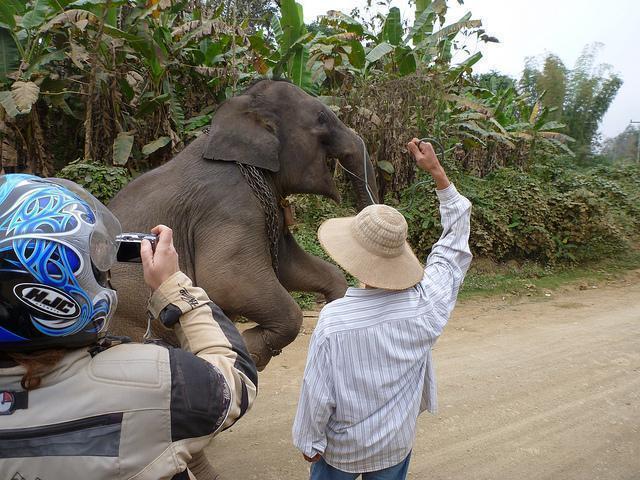Why does the man use a rope?
Answer the question by selecting the correct answer among the 4 following choices and explain your choice with a short sentence. The answer should be formatted with the following format: `Answer: choice
Rationale: rationale.`
Options: Control, tie, climb, attach. Answer: control.
Rationale: The man is an elephant trainer using objects to guide the animal. 